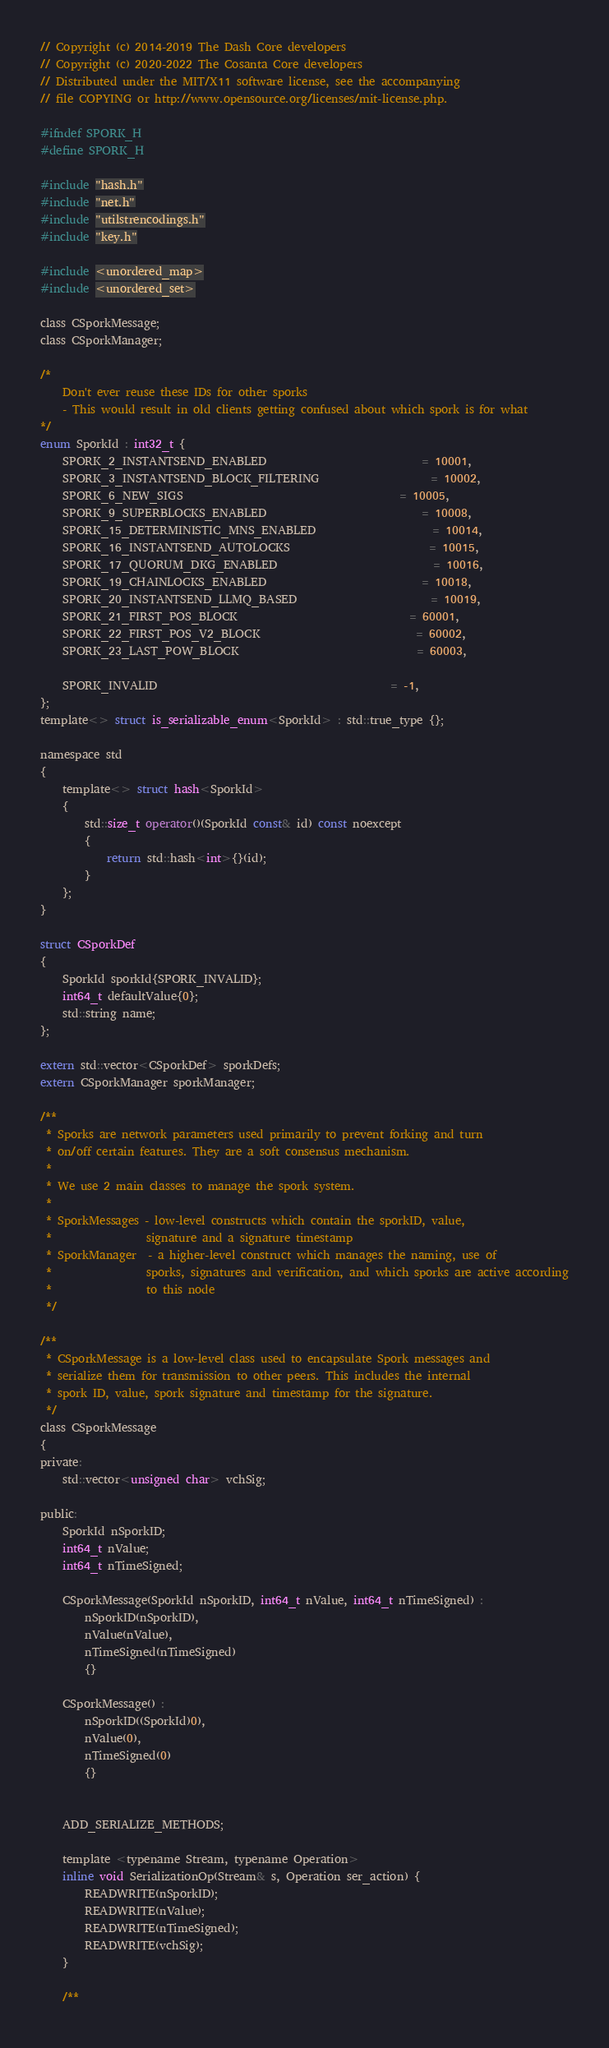Convert code to text. <code><loc_0><loc_0><loc_500><loc_500><_C_>// Copyright (c) 2014-2019 The Dash Core developers
// Copyright (c) 2020-2022 The Cosanta Core developers
// Distributed under the MIT/X11 software license, see the accompanying
// file COPYING or http://www.opensource.org/licenses/mit-license.php.

#ifndef SPORK_H
#define SPORK_H

#include "hash.h"
#include "net.h"
#include "utilstrencodings.h"
#include "key.h"

#include <unordered_map>
#include <unordered_set>

class CSporkMessage;
class CSporkManager;

/*
    Don't ever reuse these IDs for other sporks
    - This would result in old clients getting confused about which spork is for what
*/
enum SporkId : int32_t {
    SPORK_2_INSTANTSEND_ENABLED                            = 10001,
    SPORK_3_INSTANTSEND_BLOCK_FILTERING                    = 10002,
    SPORK_6_NEW_SIGS                                       = 10005,
    SPORK_9_SUPERBLOCKS_ENABLED                            = 10008,
    SPORK_15_DETERMINISTIC_MNS_ENABLED                     = 10014,
    SPORK_16_INSTANTSEND_AUTOLOCKS                         = 10015,
    SPORK_17_QUORUM_DKG_ENABLED                            = 10016,
    SPORK_19_CHAINLOCKS_ENABLED                            = 10018,
    SPORK_20_INSTANTSEND_LLMQ_BASED                        = 10019,
    SPORK_21_FIRST_POS_BLOCK                               = 60001,
    SPORK_22_FIRST_POS_V2_BLOCK                            = 60002,
    SPORK_23_LAST_POW_BLOCK                                = 60003,

    SPORK_INVALID                                          = -1,
};
template<> struct is_serializable_enum<SporkId> : std::true_type {};

namespace std
{
    template<> struct hash<SporkId>
    {
        std::size_t operator()(SporkId const& id) const noexcept
        {
            return std::hash<int>{}(id);
        }
    };
}

struct CSporkDef
{
    SporkId sporkId{SPORK_INVALID};
    int64_t defaultValue{0};
    std::string name;
};

extern std::vector<CSporkDef> sporkDefs;
extern CSporkManager sporkManager;

/**
 * Sporks are network parameters used primarily to prevent forking and turn
 * on/off certain features. They are a soft consensus mechanism.
 *
 * We use 2 main classes to manage the spork system.
 *
 * SporkMessages - low-level constructs which contain the sporkID, value,
 *                 signature and a signature timestamp
 * SporkManager  - a higher-level construct which manages the naming, use of
 *                 sporks, signatures and verification, and which sporks are active according
 *                 to this node
 */

/**
 * CSporkMessage is a low-level class used to encapsulate Spork messages and
 * serialize them for transmission to other peers. This includes the internal
 * spork ID, value, spork signature and timestamp for the signature.
 */
class CSporkMessage
{
private:
    std::vector<unsigned char> vchSig;

public:
    SporkId nSporkID;
    int64_t nValue;
    int64_t nTimeSigned;

    CSporkMessage(SporkId nSporkID, int64_t nValue, int64_t nTimeSigned) :
        nSporkID(nSporkID),
        nValue(nValue),
        nTimeSigned(nTimeSigned)
        {}

    CSporkMessage() :
        nSporkID((SporkId)0),
        nValue(0),
        nTimeSigned(0)
        {}


    ADD_SERIALIZE_METHODS;

    template <typename Stream, typename Operation>
    inline void SerializationOp(Stream& s, Operation ser_action) {
        READWRITE(nSporkID);
        READWRITE(nValue);
        READWRITE(nTimeSigned);
        READWRITE(vchSig);
    }

    /**</code> 